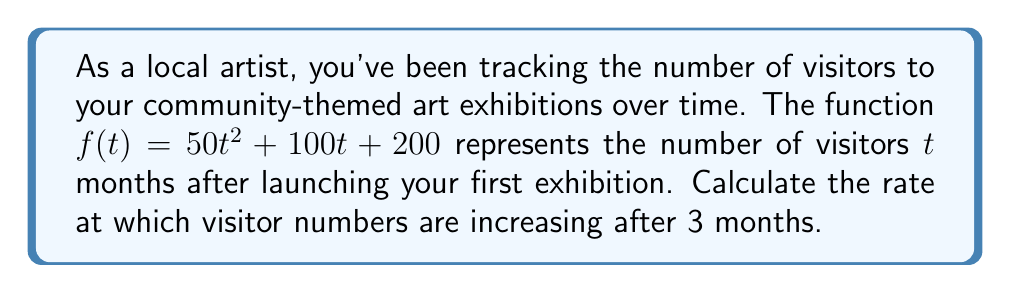What is the answer to this math problem? To find the rate at which visitor numbers are increasing after 3 months, we need to calculate the derivative of the given function and evaluate it at $t = 3$. Let's break this down step-by-step:

1. Given function: $f(t) = 50t^2 + 100t + 200$

2. To find the rate of change, we need to calculate $f'(t)$:
   $f'(t) = \frac{d}{dt}(50t^2 + 100t + 200)$

3. Using the power rule and constant rule of derivatives:
   $f'(t) = 100t + 100$

4. This derivative function $f'(t)$ represents the instantaneous rate of change in visitor numbers at any time $t$.

5. To find the rate of change after 3 months, we evaluate $f'(3)$:
   $f'(3) = 100(3) + 100 = 300 + 100 = 400$

Therefore, after 3 months, the number of visitors is increasing at a rate of 400 visitors per month.
Answer: 400 visitors/month 